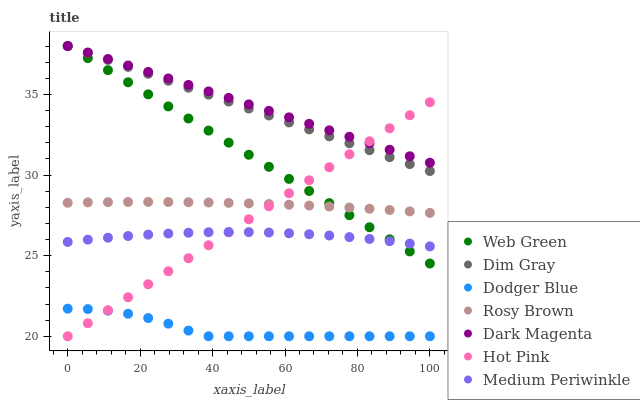Does Dodger Blue have the minimum area under the curve?
Answer yes or no. Yes. Does Dark Magenta have the maximum area under the curve?
Answer yes or no. Yes. Does Rosy Brown have the minimum area under the curve?
Answer yes or no. No. Does Rosy Brown have the maximum area under the curve?
Answer yes or no. No. Is Web Green the smoothest?
Answer yes or no. Yes. Is Dodger Blue the roughest?
Answer yes or no. Yes. Is Dark Magenta the smoothest?
Answer yes or no. No. Is Dark Magenta the roughest?
Answer yes or no. No. Does Dodger Blue have the lowest value?
Answer yes or no. Yes. Does Rosy Brown have the lowest value?
Answer yes or no. No. Does Web Green have the highest value?
Answer yes or no. Yes. Does Rosy Brown have the highest value?
Answer yes or no. No. Is Medium Periwinkle less than Rosy Brown?
Answer yes or no. Yes. Is Web Green greater than Dodger Blue?
Answer yes or no. Yes. Does Hot Pink intersect Dodger Blue?
Answer yes or no. Yes. Is Hot Pink less than Dodger Blue?
Answer yes or no. No. Is Hot Pink greater than Dodger Blue?
Answer yes or no. No. Does Medium Periwinkle intersect Rosy Brown?
Answer yes or no. No. 